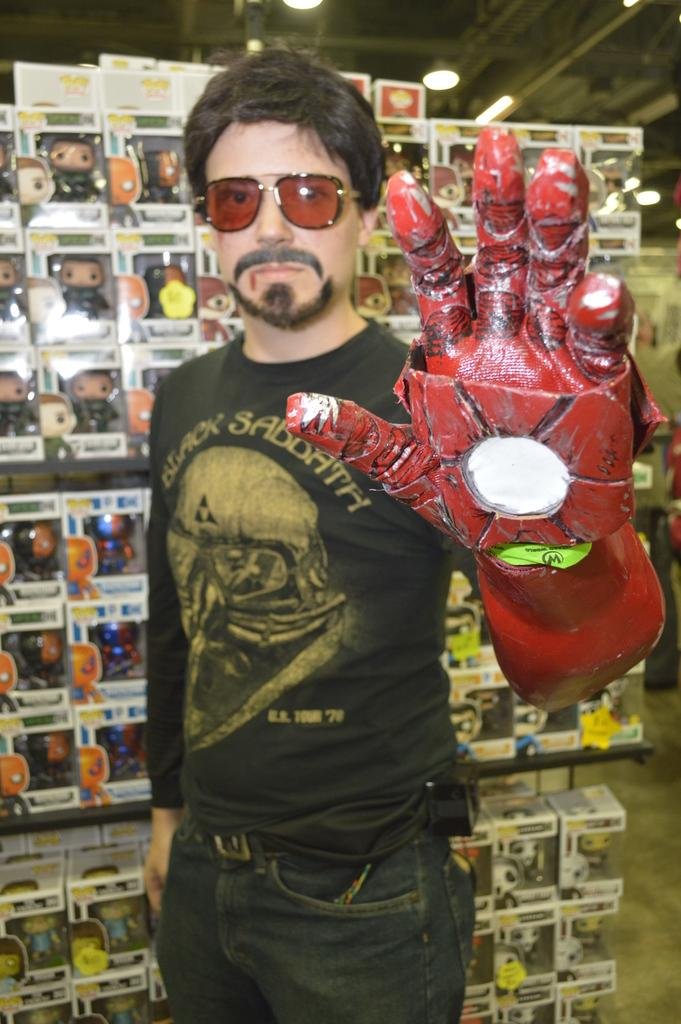Who is present in the image? There is a man in the image. What is the man wearing on his face? The man is wearing spectacles. What is the man wearing on his hand? The man is wearing a glove. What can be seen behind the man? There are toys in boxes behind the man. What can be seen providing illumination in the image? There are lights visible in the image. What type of property does the man own, as seen in the image? There is no indication of property ownership in the image. Can you tell me how many breaths the man takes in the image? The image does not show the man breathing, so it is impossible to determine the number of breaths. 